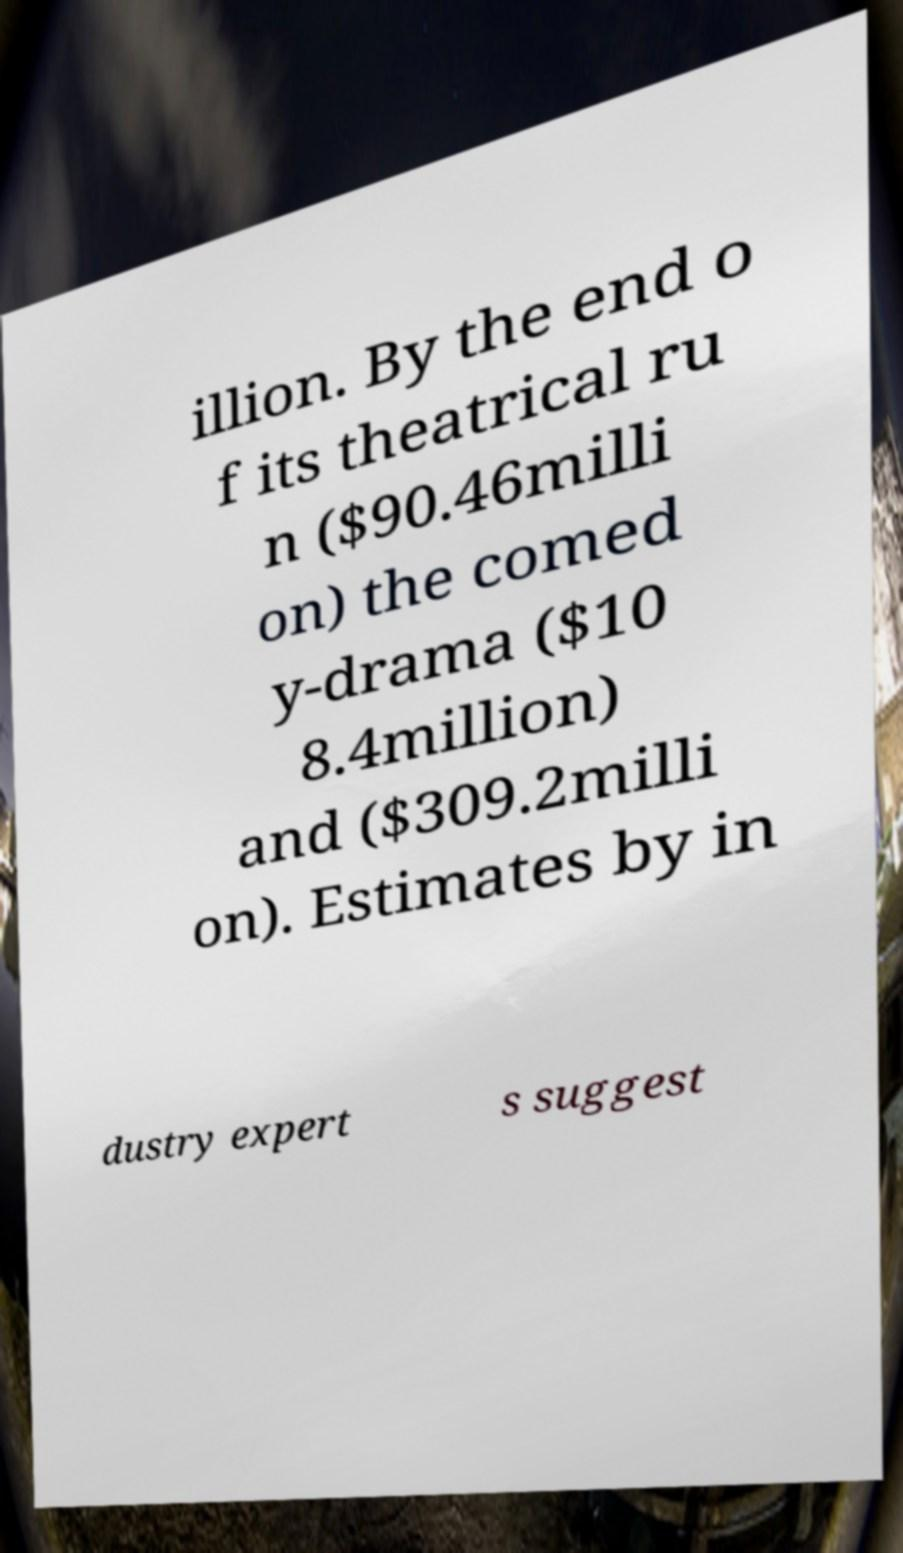Can you read and provide the text displayed in the image?This photo seems to have some interesting text. Can you extract and type it out for me? illion. By the end o f its theatrical ru n ($90.46milli on) the comed y-drama ($10 8.4million) and ($309.2milli on). Estimates by in dustry expert s suggest 